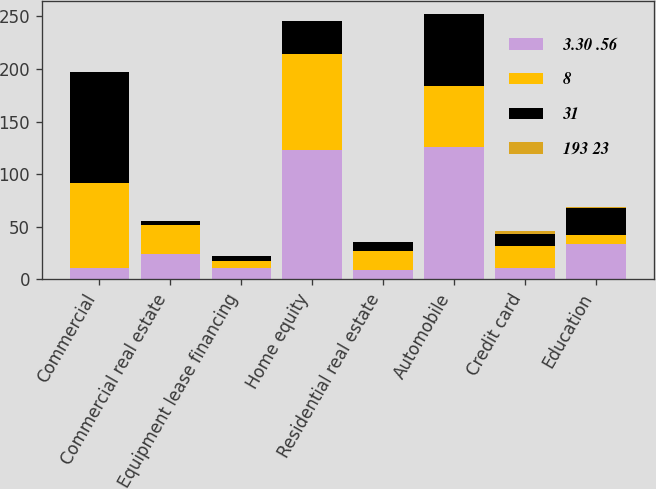Convert chart. <chart><loc_0><loc_0><loc_500><loc_500><stacked_bar_chart><ecel><fcel>Commercial<fcel>Commercial real estate<fcel>Equipment lease financing<fcel>Home equity<fcel>Residential real estate<fcel>Automobile<fcel>Credit card<fcel>Education<nl><fcel>3.30 .56<fcel>11<fcel>24<fcel>11<fcel>123<fcel>9<fcel>126<fcel>11<fcel>34<nl><fcel>8<fcel>81<fcel>28<fcel>7<fcel>91<fcel>18<fcel>58<fcel>21<fcel>8<nl><fcel>31<fcel>105<fcel>4<fcel>4<fcel>32<fcel>9<fcel>68<fcel>11<fcel>26<nl><fcel>193 23<fcel>0.1<fcel>0.01<fcel>0.05<fcel>0.11<fcel>0.06<fcel>0.54<fcel>3.06<fcel>0.54<nl></chart> 